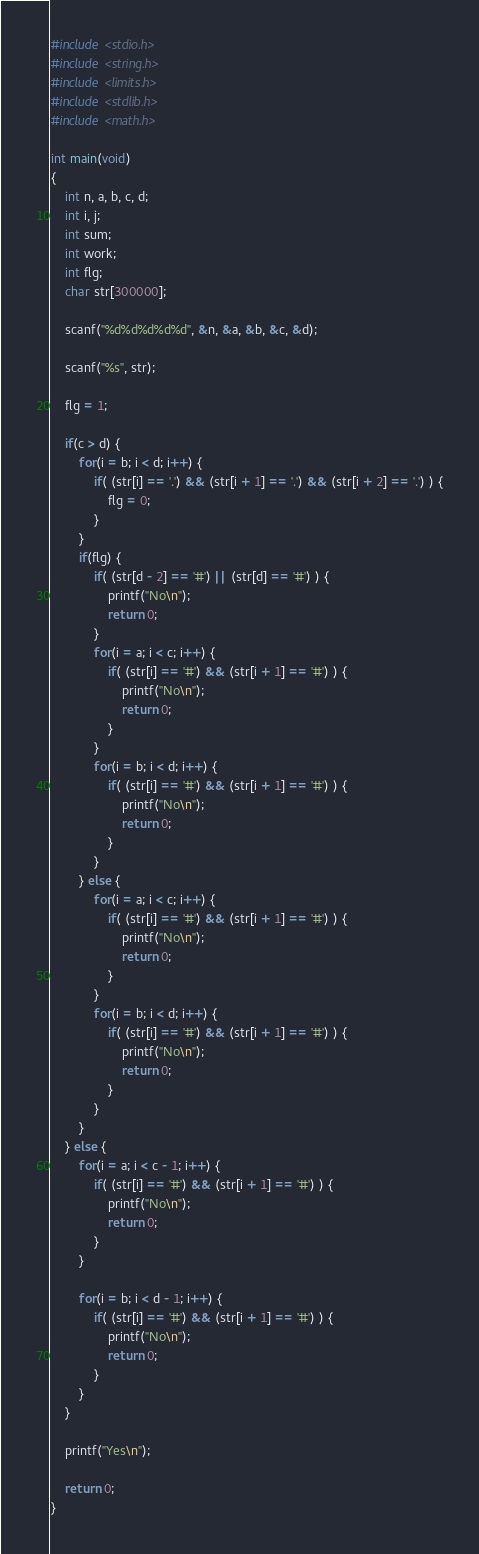Convert code to text. <code><loc_0><loc_0><loc_500><loc_500><_C_>#include <stdio.h>
#include <string.h>
#include <limits.h>
#include <stdlib.h>
#include <math.h>

int main(void)
{
	int n, a, b, c, d;
	int i, j;
	int sum;
	int work;
	int flg;
	char str[300000];
	
	scanf("%d%d%d%d%d", &n, &a, &b, &c, &d);
	
	scanf("%s", str);
	
	flg = 1;
	
	if(c > d) {
		for(i = b; i < d; i++) {
			if( (str[i] == '.') && (str[i + 1] == '.') && (str[i + 2] == '.') ) {
				flg = 0;
			}
		}
		if(flg) {
			if( (str[d - 2] == '#') || (str[d] == '#') ) {
				printf("No\n");
				return 0;
			}
			for(i = a; i < c; i++) {
				if( (str[i] == '#') && (str[i + 1] == '#') ) {
					printf("No\n");
					return 0;
				}
			}
			for(i = b; i < d; i++) {
				if( (str[i] == '#') && (str[i + 1] == '#') ) {
					printf("No\n");
					return 0;
				}
			}
		} else {
			for(i = a; i < c; i++) {
				if( (str[i] == '#') && (str[i + 1] == '#') ) {
					printf("No\n");
					return 0;
				}
			}
			for(i = b; i < d; i++) {
				if( (str[i] == '#') && (str[i + 1] == '#') ) {
					printf("No\n");
					return 0;
				}
			}
		}
	} else {
		for(i = a; i < c - 1; i++) {
			if( (str[i] == '#') && (str[i + 1] == '#') ) {
				printf("No\n");
				return 0;
			}
		}
		
		for(i = b; i < d - 1; i++) {
			if( (str[i] == '#') && (str[i + 1] == '#') ) {
				printf("No\n");
				return 0;
			}
		}
	}
	
	printf("Yes\n");
	
	return 0;
}</code> 